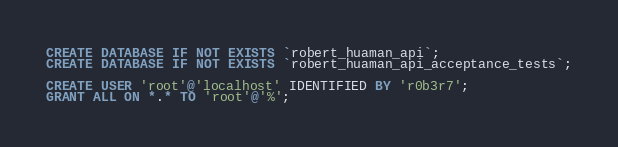Convert code to text. <code><loc_0><loc_0><loc_500><loc_500><_SQL_>CREATE DATABASE IF NOT EXISTS `robert_huaman_api`;
CREATE DATABASE IF NOT EXISTS `robert_huaman_api_acceptance_tests`;

CREATE USER 'root'@'localhost' IDENTIFIED BY 'r0b3r7';
GRANT ALL ON *.* TO 'root'@'%';
</code> 